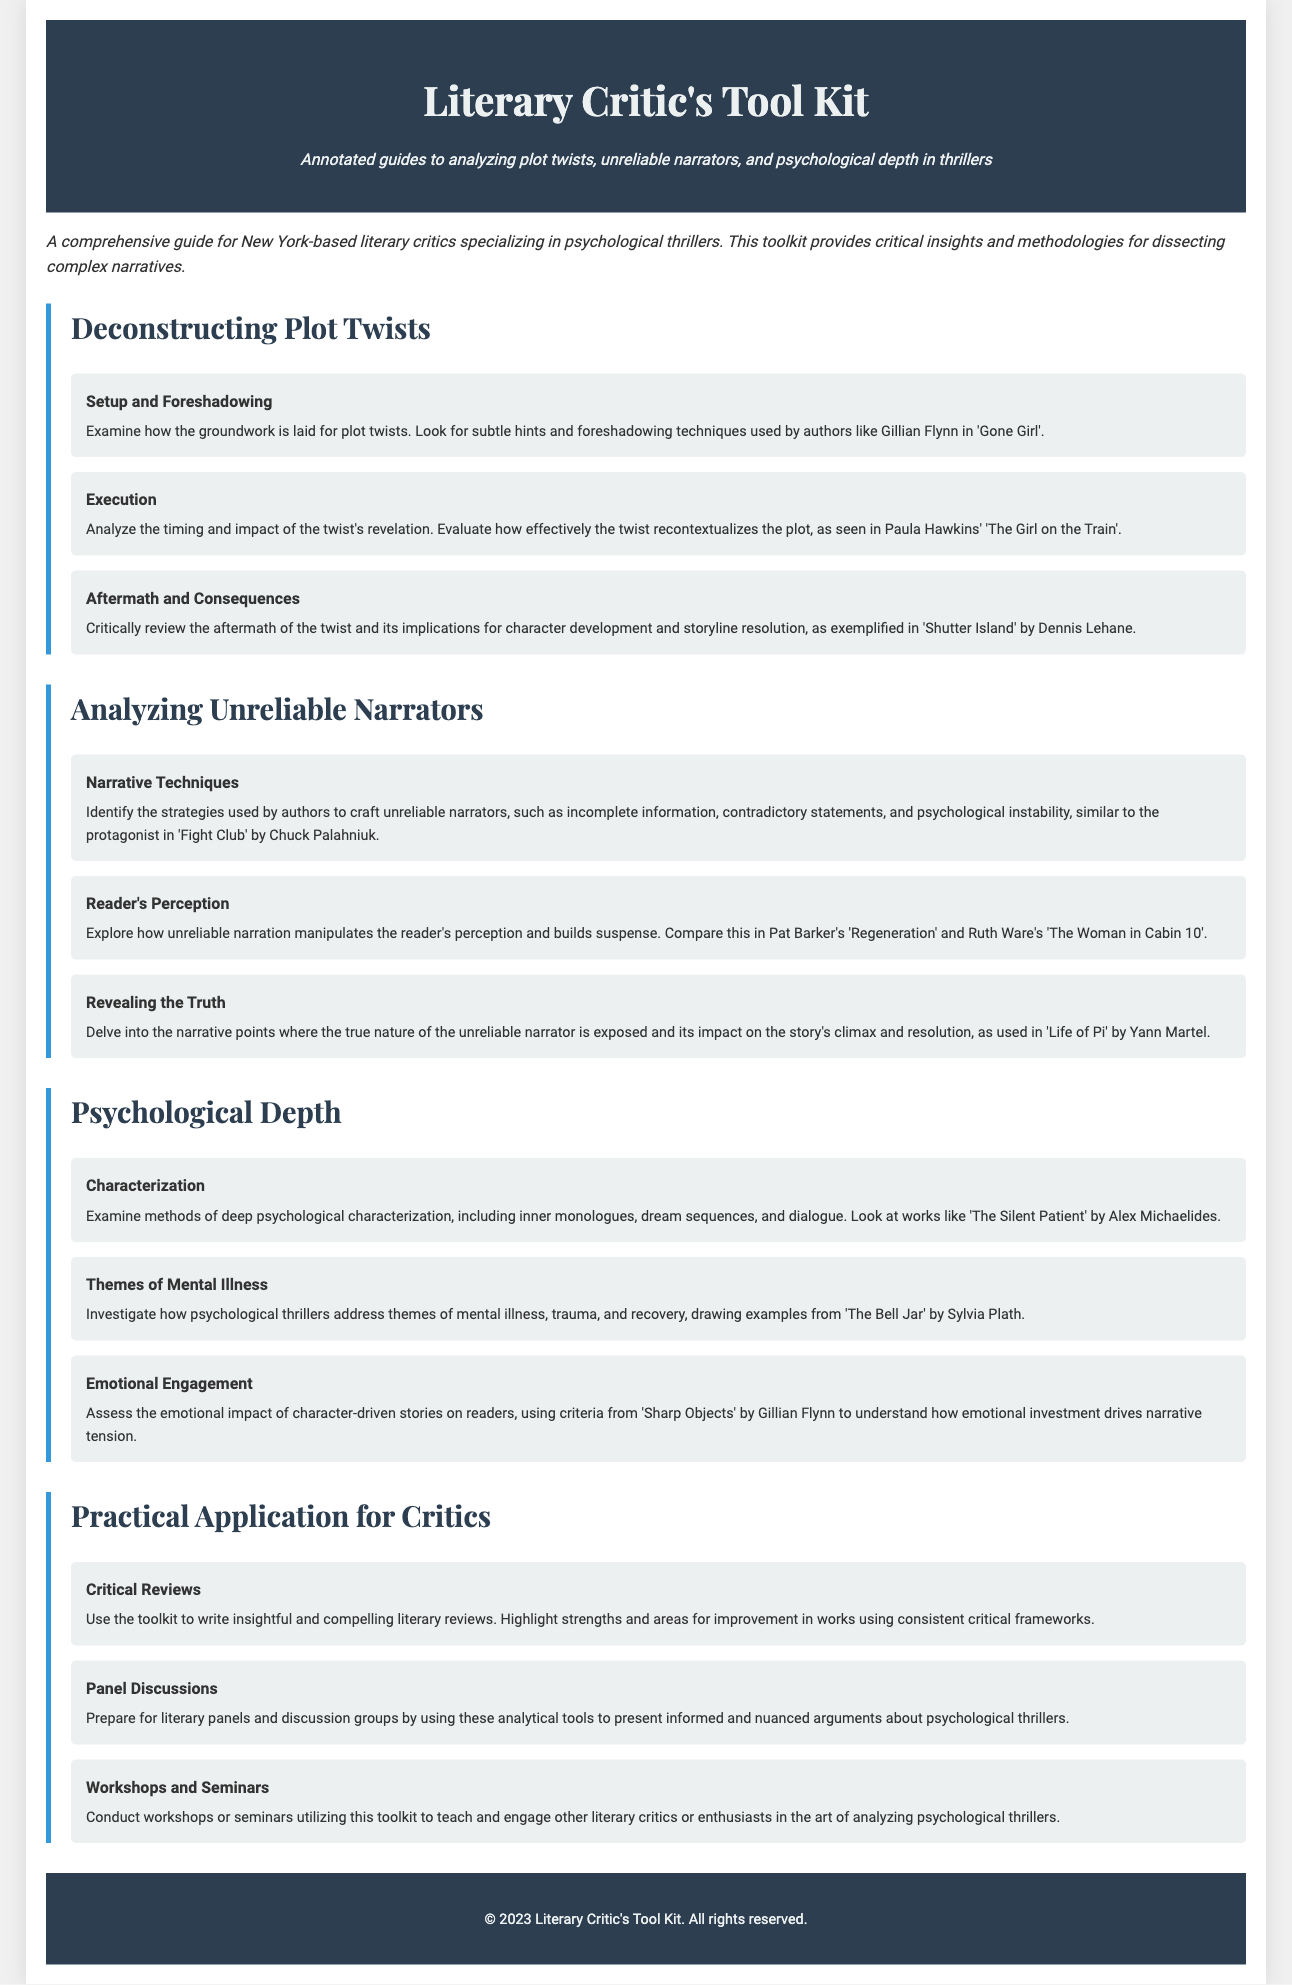what is the title of the document? The title is prominently displayed in the header section of the document.
Answer: Literary Critic's Tool Kit who is the intended audience for this toolkit? The document specifies who can benefit from the toolkit in its main description.
Answer: New York-based literary critics what is one focus area of the toolkit? The document outlines several focus areas in different sections, specifically addressing various analytical methods.
Answer: Psychological depth name a notable author referenced for plot twist analysis. The document cites specific authors in relation to plot twists as examples.
Answer: Gillian Flynn how many sections are dedicated to analyzing unreliable narrators? The content is organized into multiple sections, and one of them focuses specifically on this topic.
Answer: Three what type of activities does the toolkit suggest for practical application? The document discusses various applications for critics and lists specific activities in the relevant section.
Answer: Workshops and Seminars what author is mentioned in relation to themes of mental illness? The document includes examples related to this theme, citing particular authors.
Answer: Sylvia Plath what color is used in the footer background? The document visually describes the color scheme used within different elements.
Answer: Dark blue 